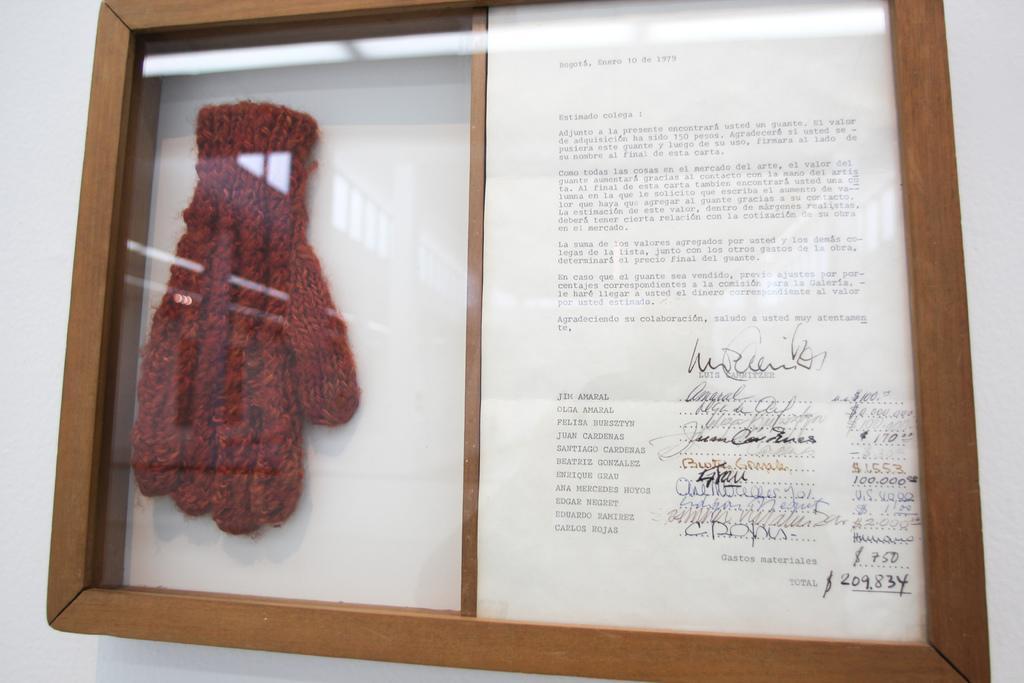Describe this image in one or two sentences. In this image there is a wall, for that wall there frame, in that frame there is a letter and glove. 